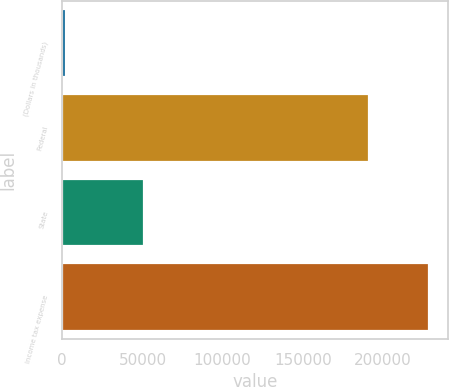Convert chart to OTSL. <chart><loc_0><loc_0><loc_500><loc_500><bar_chart><fcel>(Dollars in thousands)<fcel>Federal<fcel>State<fcel>Income tax expense<nl><fcel>2015<fcel>191194<fcel>50815<fcel>228754<nl></chart> 